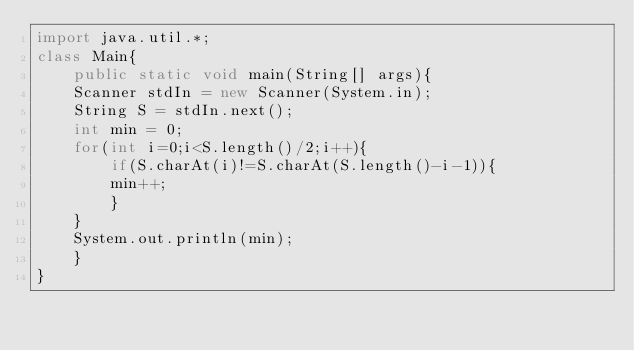Convert code to text. <code><loc_0><loc_0><loc_500><loc_500><_Java_>import java.util.*;
class Main{
    public static void main(String[] args){
	Scanner stdIn = new Scanner(System.in);
	String S = stdIn.next();
	int min = 0;
	for(int i=0;i<S.length()/2;i++){
	    if(S.charAt(i)!=S.charAt(S.length()-i-1)){
		min++;
	    }
	}
	System.out.println(min);
    }
}
</code> 